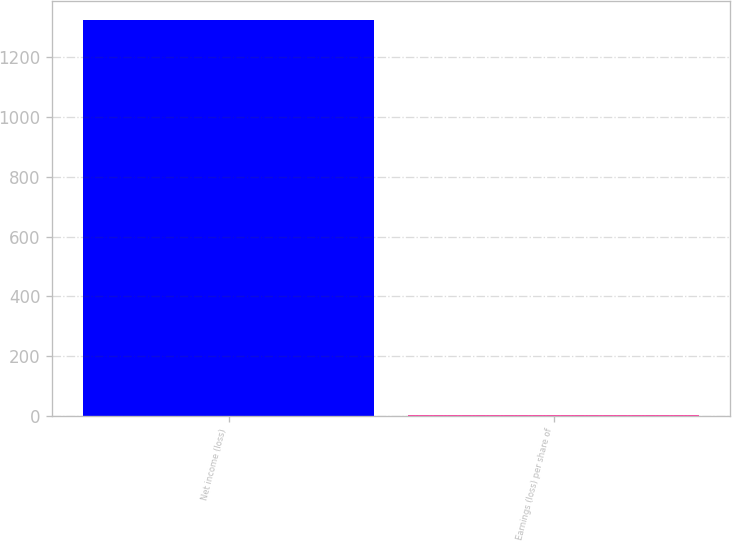Convert chart to OTSL. <chart><loc_0><loc_0><loc_500><loc_500><bar_chart><fcel>Net income (loss)<fcel>Earnings (loss) per share of<nl><fcel>1324<fcel>1.54<nl></chart> 